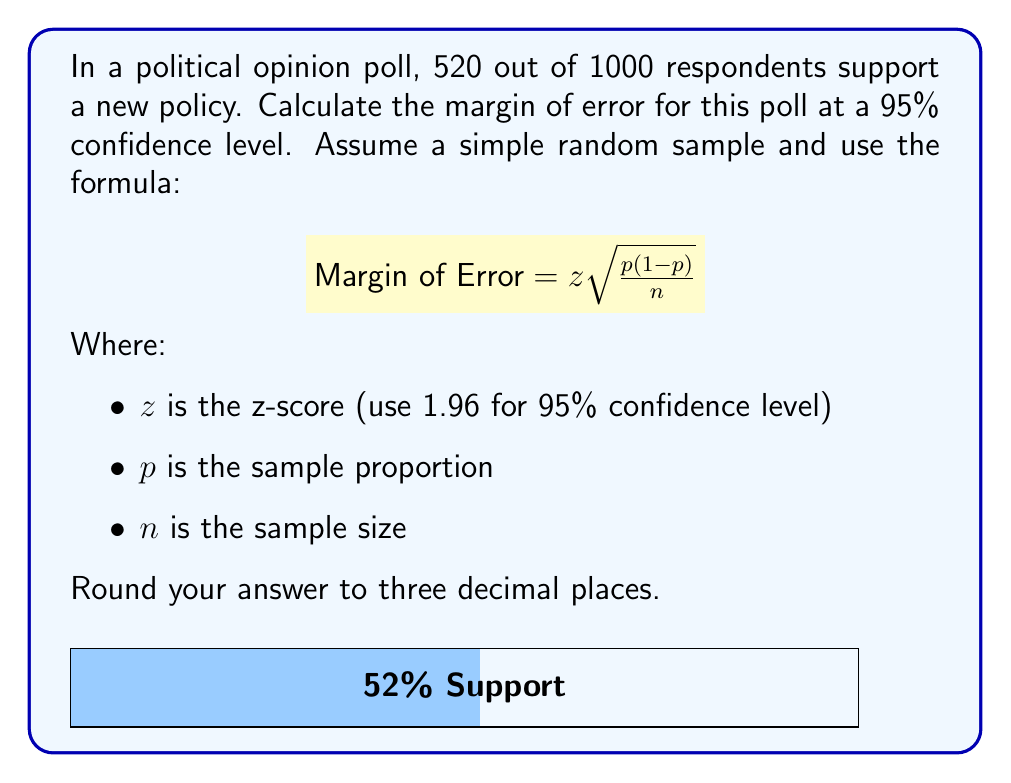Solve this math problem. Let's approach this step-by-step:

1) First, we need to identify our variables:
   $z = 1.96$ (for 95% confidence level)
   $n = 1000$ (sample size)
   $p = 520/1000 = 0.52$ (sample proportion)

2) Now, let's plug these into our formula:

   $$ \text{Margin of Error} = 1.96 \sqrt{\frac{0.52(1-0.52)}{1000}} $$

3) Simplify inside the square root:
   
   $$ \text{Margin of Error} = 1.96 \sqrt{\frac{0.52(0.48)}{1000}} $$

4) Calculate inside the square root:

   $$ \text{Margin of Error} = 1.96 \sqrt{\frac{0.2496}{1000}} = 1.96 \sqrt{0.0002496} $$

5) Calculate the square root:

   $$ \text{Margin of Error} = 1.96 * 0.015800 $$

6) Multiply:

   $$ \text{Margin of Error} = 0.030968 $$

7) Round to three decimal places:

   $$ \text{Margin of Error} = 0.031 $$

This means that we can be 95% confident that the true population proportion falls within ±3.1 percentage points of our sample proportion.
Answer: 0.031 or 3.1% 